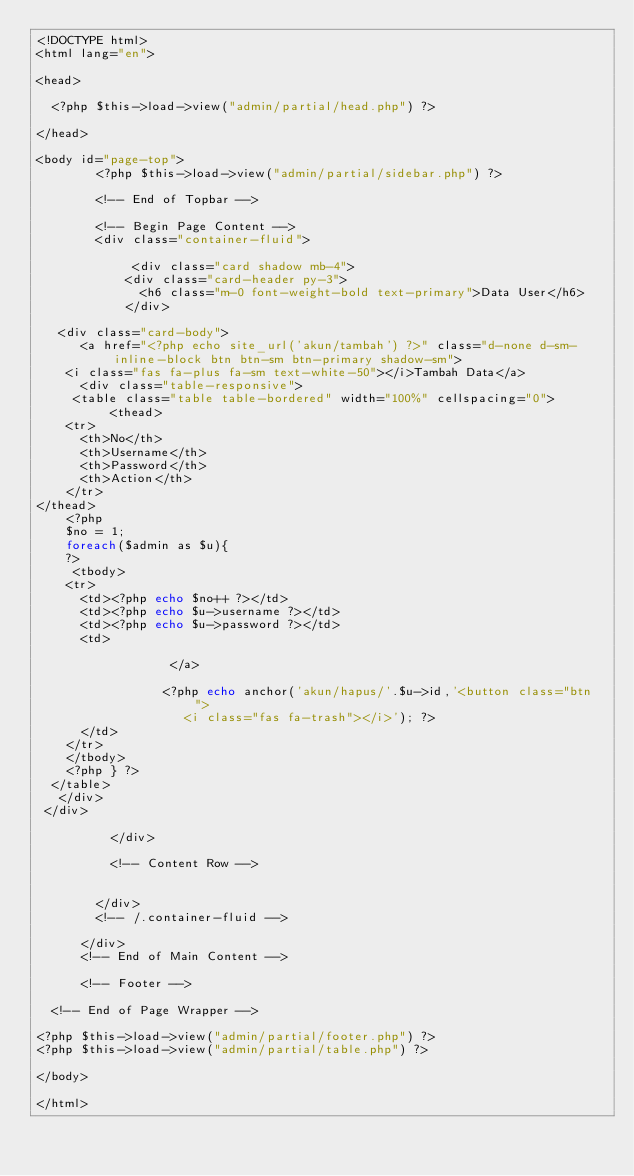Convert code to text. <code><loc_0><loc_0><loc_500><loc_500><_PHP_><!DOCTYPE html>
<html lang="en">

<head>

  <?php $this->load->view("admin/partial/head.php") ?>

</head>

<body id="page-top">
        <?php $this->load->view("admin/partial/sidebar.php") ?>
    
        <!-- End of Topbar -->

        <!-- Begin Page Content -->
        <div class="container-fluid">

             <div class="card shadow mb-4">
            <div class="card-header py-3">
              <h6 class="m-0 font-weight-bold text-primary">Data User</h6>
            </div>
            
	 <div class="card-body">
     	<a href="<?php echo site_url('akun/tambah') ?>" class="d-none d-sm-inline-block btn btn-sm btn-primary shadow-sm">
    <i class="fas fa-plus fa-sm text-white-50"></i>Tambah Data</a>
      <div class="table-responsive">
     <table class="table table-bordered" width="100%" cellspacing="0">
          <thead>
		<tr>
			<th>No</th>
			<th>Username</th>
			<th>Password</th>
			<th>Action</th>
		</tr>
</thead>
		<?php 
		$no = 1;
		foreach($admin as $u){ 
		?>
		 <tbody>
		<tr>
			<td><?php echo $no++ ?></td>
			<td><?php echo $u->username ?></td>
			<td><?php echo $u->password ?></td>
			<td>
          
                  </a>
			  
                 <?php echo anchor('akun/hapus/'.$u->id,'<button class="btn  ">
                    <i class="fas fa-trash"></i>'); ?>
			</td>
		</tr>
		</tbody>
		<?php } ?>
	</table>
   </div>
 </div>
	 
          </div>

          <!-- Content Row -->


        </div>
        <!-- /.container-fluid -->

      </div>
      <!-- End of Main Content -->

      <!-- Footer -->

  <!-- End of Page Wrapper -->

<?php $this->load->view("admin/partial/footer.php") ?>
<?php $this->load->view("admin/partial/table.php") ?>

</body>

</html>
</code> 